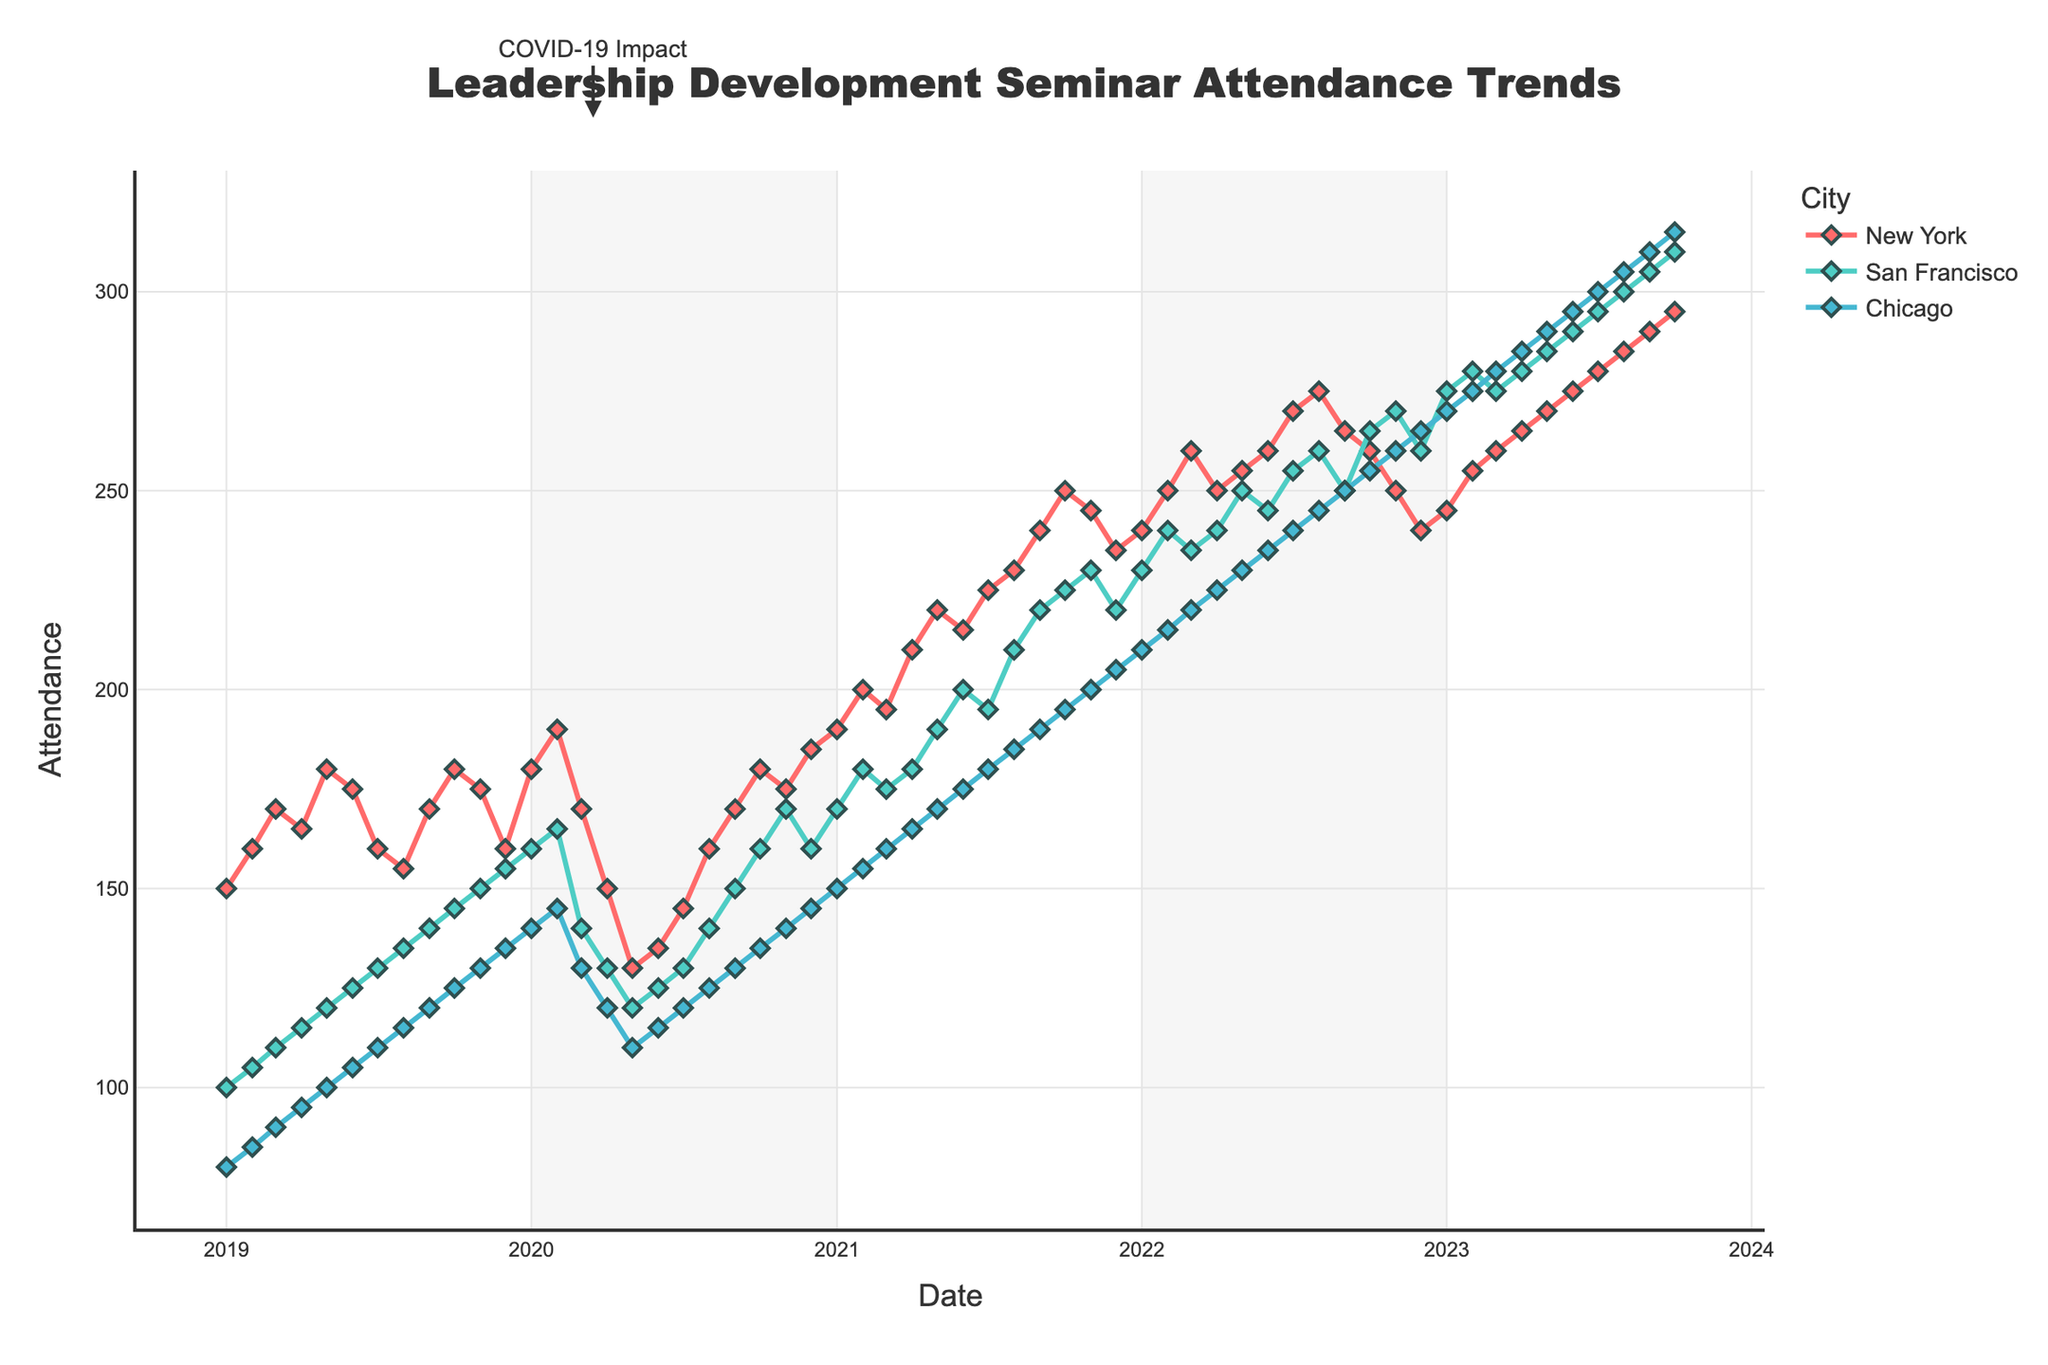Which city had the highest attendance in October 2023? The plot shows attendance for three cities: New York, San Francisco, and Chicago. In October 2023, New York had the highest attendance at 295, followed by San Francisco at 310, and then Chicago at 315.
Answer: Chicago What was the overall trend for seminar attendance in New York from 2019 to 2023? Observing the plot from 2019 to 2023, New York's attendance shows fluctuations initially but then increases consistently after 2021, peaking towards the end at 295 in October 2023.
Answer: Increasing trend How did COVID-19 impact seminar attendance in March 2020 across all cities? The plot has an annotation marking "COVID-19 Impact" around March 2020. All cities display a noticeable drop in attendance around this period.
Answer: Negative impact Which city showed the most dramatic increase in attendance over the five-year period? By comparing the slopes of the attendance lines for each city from 2019 to 2023, Chicago shows the steepest incline, indicating the most dramatic increase in attendance.
Answer: Chicago Did any city show a consistent monthly increase without any dips over the entire period? By analyzing the plot, it is clear that none of the cities showed a consistent monthly increase without any dips; all cities experienced at least some months where attendance either plateaued or dropped.
Answer: No What's the difference in attendance between San Francisco and Chicago in January 2019? The plot shows San Francisco's attendance at 100 and Chicago's at 80 in January 2019. The difference in attendance is calculated by subtracting Chicago's attendance from San Francisco's.
Answer: 20 Which month in 2020 had the lowest attendance for New York? According to the plot, May 2020 had the lowest attendance in New York at 130.
Answer: May 2020 What was the attendance value for San Francisco during its peak month? The peak attendance for San Francisco, as seen in the plot, was in October 2023 with 310 attendees.
Answer: 310 How does the attendance in New York in March 2020 compare to March 2021? In March 2020, New York's attendance was 170, whereas in March 2021, it rose to 195.
Answer: Higher in March 2021 Is there a significant variation in attendance patterns between the three cities? The attendance patterns for the cities differ significantly. New York and San Francisco showed clear impacts from COVID-19, but Chicago rebounded more strongly and consistently after the initial dip.
Answer: Yes 